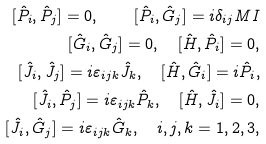<formula> <loc_0><loc_0><loc_500><loc_500>[ \hat { P } _ { i } , \hat { P } _ { j } ] = 0 , \quad [ \hat { P } _ { i } , \hat { G } _ { j } ] = i \delta _ { i j } M I \\ [ \hat { G } _ { i } , \hat { G } _ { j } ] = 0 , \quad [ \hat { H } , \hat { P } _ { i } ] = 0 , \\ [ \hat { J } _ { i } , \hat { J } _ { j } ] = i \varepsilon _ { i j k } \hat { J } _ { k } , \quad [ \hat { H } , \hat { G } _ { i } ] = i \hat { P } _ { i } , \\ [ \hat { J } _ { i } , \hat { P } _ { j } ] = i \varepsilon _ { i j k } \hat { P } _ { k } , \quad [ \hat { H } , \hat { J } _ { i } ] = 0 , \\ [ \hat { J } _ { i } , \hat { G } _ { j } ] = i \varepsilon _ { i j k } \hat { G } _ { k } , \quad i , j , k = 1 , 2 , 3 ,</formula> 